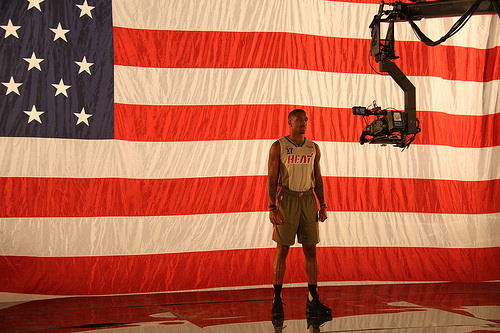<image>
Can you confirm if the man is in front of the camera? Yes. The man is positioned in front of the camera, appearing closer to the camera viewpoint. Where is the men in relation to the camera? Is it in front of the camera? Yes. The men is positioned in front of the camera, appearing closer to the camera viewpoint. 